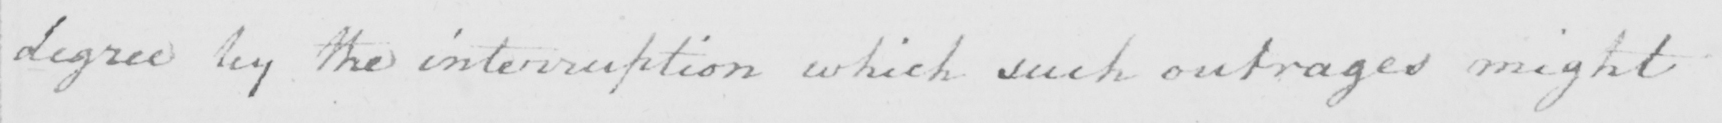Transcribe the text shown in this historical manuscript line. degree by the interruption which such outrages might 